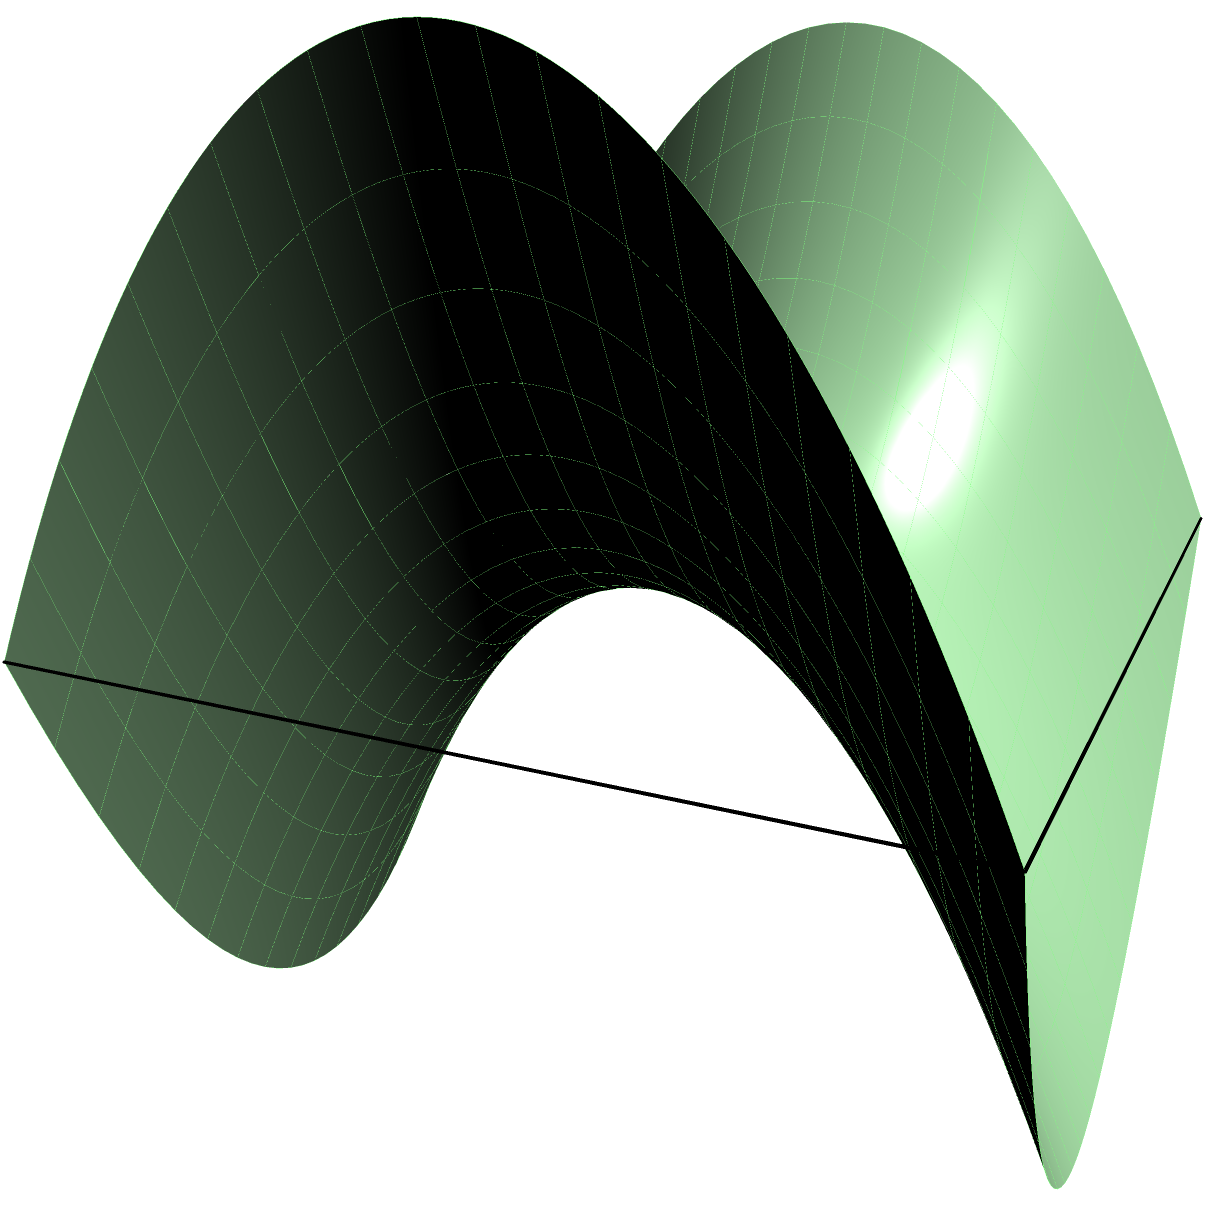As an election monitoring officer, you're tasked with planning the most efficient route for observers between two polling stations located on a saddle-shaped terrain. The terrain can be modeled by the function $z = x^2 - y^2$. If the stations are at points $A(-1.5, -1.5)$ and $B(1.5, 1.5)$, which path would likely be the shortest between these points?

a) A straight line between A and B
b) A curve following the "valley" of the saddle
c) A curve following the "ridge" of the saddle
d) A zigzag path alternating between valley and ridge To determine the shortest path between two points on a saddle-shaped surface, we need to consider the principles of geodesics in non-Euclidean geometry. Let's approach this step-by-step:

1) The surface is described by $z = x^2 - y^2$, which is a hyperbolic paraboloid or "saddle" shape.

2) In Euclidean geometry, the shortest path between two points is a straight line. However, on curved surfaces, the shortest path (geodesic) can be a curve.

3) On a saddle surface, geodesics tend to follow a balance between the "valley" and the "ridge" of the saddle.

4) The points $A(-1.5, -1.5)$ and $B(1.5, 1.5)$ are diagonally opposite on the saddle.

5) A straight line between these points (option a) would not follow the curvature of the surface and thus would not be the shortest path.

6) Following either the valley (option b) or the ridge (option c) exclusively would create a longer path than necessary.

7) A zigzag path (option d) would clearly be longer than a more direct route.

8) The actual geodesic would be a curve that balances between the valley and ridge, starting at A, curving slightly towards the center of the saddle, and then curving out to reach B.

9) This balanced curve is represented by the orange line in the diagram.

Therefore, while none of the given options exactly describe the true geodesic, the closest answer would be a curve that follows a balanced path between the valley and ridge of the saddle.
Answer: A curve balancing between valley and ridge 